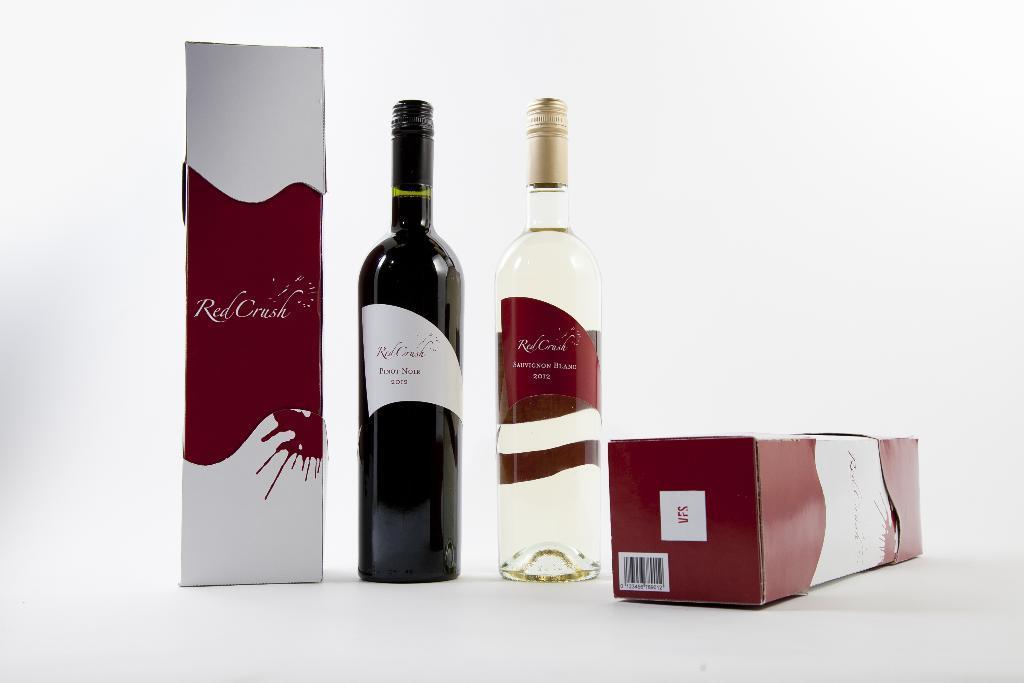How would you summarize this image in a sentence or two? In this image there are two bottles and two packets. One bottle is black in color another is transparent. 